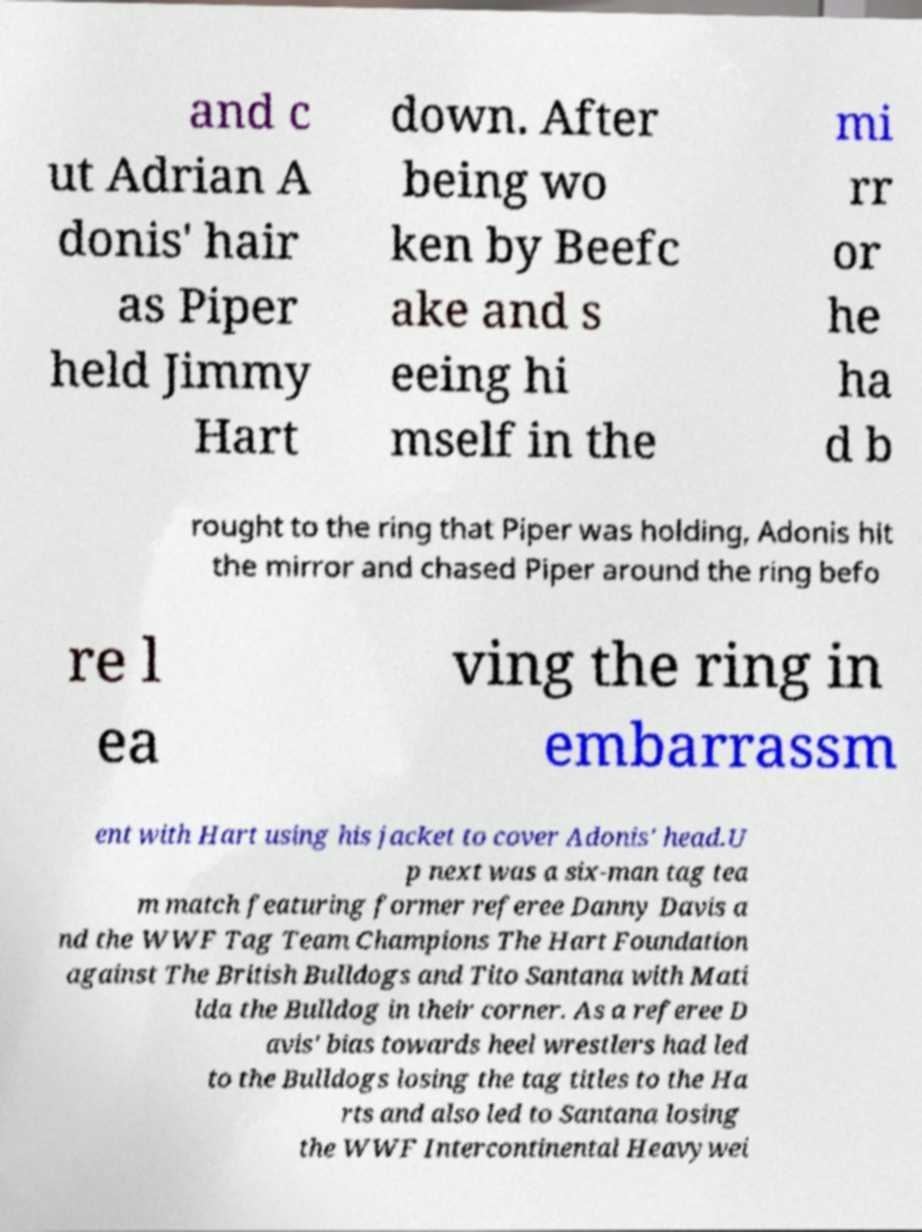Please read and relay the text visible in this image. What does it say? and c ut Adrian A donis' hair as Piper held Jimmy Hart down. After being wo ken by Beefc ake and s eeing hi mself in the mi rr or he ha d b rought to the ring that Piper was holding, Adonis hit the mirror and chased Piper around the ring befo re l ea ving the ring in embarrassm ent with Hart using his jacket to cover Adonis' head.U p next was a six-man tag tea m match featuring former referee Danny Davis a nd the WWF Tag Team Champions The Hart Foundation against The British Bulldogs and Tito Santana with Mati lda the Bulldog in their corner. As a referee D avis' bias towards heel wrestlers had led to the Bulldogs losing the tag titles to the Ha rts and also led to Santana losing the WWF Intercontinental Heavywei 